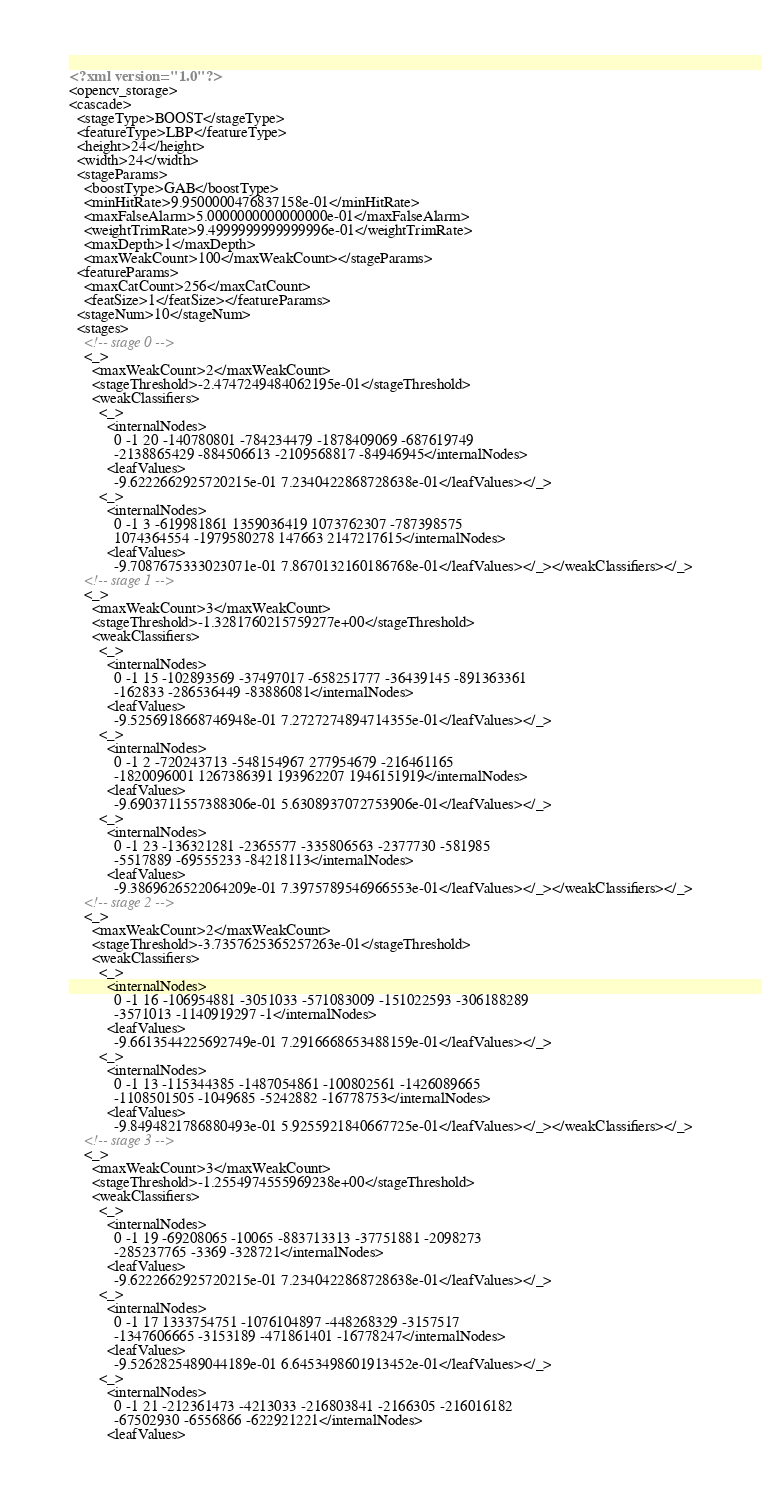Convert code to text. <code><loc_0><loc_0><loc_500><loc_500><_XML_><?xml version="1.0"?>
<opencv_storage>
<cascade>
  <stageType>BOOST</stageType>
  <featureType>LBP</featureType>
  <height>24</height>
  <width>24</width>
  <stageParams>
    <boostType>GAB</boostType>
    <minHitRate>9.9500000476837158e-01</minHitRate>
    <maxFalseAlarm>5.0000000000000000e-01</maxFalseAlarm>
    <weightTrimRate>9.4999999999999996e-01</weightTrimRate>
    <maxDepth>1</maxDepth>
    <maxWeakCount>100</maxWeakCount></stageParams>
  <featureParams>
    <maxCatCount>256</maxCatCount>
    <featSize>1</featSize></featureParams>
  <stageNum>10</stageNum>
  <stages>
    <!-- stage 0 -->
    <_>
      <maxWeakCount>2</maxWeakCount>
      <stageThreshold>-2.4747249484062195e-01</stageThreshold>
      <weakClassifiers>
        <_>
          <internalNodes>
            0 -1 20 -140780801 -784234479 -1878409069 -687619749
            -2138865429 -884506613 -2109568817 -84946945</internalNodes>
          <leafValues>
            -9.6222662925720215e-01 7.2340422868728638e-01</leafValues></_>
        <_>
          <internalNodes>
            0 -1 3 -619981861 1359036419 1073762307 -787398575
            1074364554 -1979580278 147663 2147217615</internalNodes>
          <leafValues>
            -9.7087675333023071e-01 7.8670132160186768e-01</leafValues></_></weakClassifiers></_>
    <!-- stage 1 -->
    <_>
      <maxWeakCount>3</maxWeakCount>
      <stageThreshold>-1.3281760215759277e+00</stageThreshold>
      <weakClassifiers>
        <_>
          <internalNodes>
            0 -1 15 -102893569 -37497017 -658251777 -36439145 -891363361
            -162833 -286536449 -83886081</internalNodes>
          <leafValues>
            -9.5256918668746948e-01 7.2727274894714355e-01</leafValues></_>
        <_>
          <internalNodes>
            0 -1 2 -720243713 -548154967 277954679 -216461165
            -1820096001 1267386391 193962207 1946151919</internalNodes>
          <leafValues>
            -9.6903711557388306e-01 5.6308937072753906e-01</leafValues></_>
        <_>
          <internalNodes>
            0 -1 23 -136321281 -2365577 -335806563 -2377730 -581985
            -5517889 -69555233 -84218113</internalNodes>
          <leafValues>
            -9.3869626522064209e-01 7.3975789546966553e-01</leafValues></_></weakClassifiers></_>
    <!-- stage 2 -->
    <_>
      <maxWeakCount>2</maxWeakCount>
      <stageThreshold>-3.7357625365257263e-01</stageThreshold>
      <weakClassifiers>
        <_>
          <internalNodes>
            0 -1 16 -106954881 -3051033 -571083009 -151022593 -306188289
            -3571013 -1140919297 -1</internalNodes>
          <leafValues>
            -9.6613544225692749e-01 7.2916668653488159e-01</leafValues></_>
        <_>
          <internalNodes>
            0 -1 13 -115344385 -1487054861 -100802561 -1426089665
            -1108501505 -1049685 -5242882 -16778753</internalNodes>
          <leafValues>
            -9.8494821786880493e-01 5.9255921840667725e-01</leafValues></_></weakClassifiers></_>
    <!-- stage 3 -->
    <_>
      <maxWeakCount>3</maxWeakCount>
      <stageThreshold>-1.2554974555969238e+00</stageThreshold>
      <weakClassifiers>
        <_>
          <internalNodes>
            0 -1 19 -69208065 -10065 -883713313 -37751881 -2098273
            -285237765 -3369 -328721</internalNodes>
          <leafValues>
            -9.6222662925720215e-01 7.2340422868728638e-01</leafValues></_>
        <_>
          <internalNodes>
            0 -1 17 1333754751 -1076104897 -448268329 -3157517
            -1347606665 -3153189 -471861401 -16778247</internalNodes>
          <leafValues>
            -9.5262825489044189e-01 6.6453498601913452e-01</leafValues></_>
        <_>
          <internalNodes>
            0 -1 21 -212361473 -4213033 -216803841 -2166305 -216016182
            -67502930 -6556866 -622921221</internalNodes>
          <leafValues></code> 